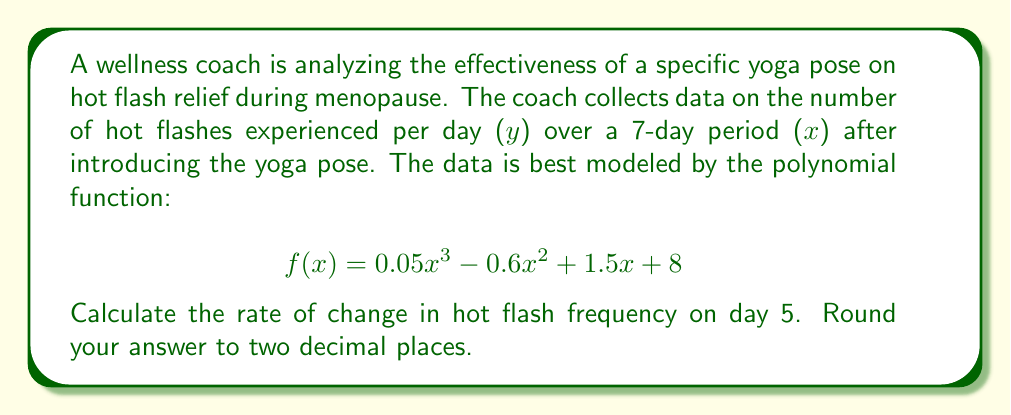What is the answer to this math problem? To find the rate of change in hot flash frequency on day 5, we need to calculate the derivative of the given polynomial function and evaluate it at x = 5.

Step 1: Find the derivative of f(x).
$$f(x) = 0.05x^3 - 0.6x^2 + 1.5x + 8$$
$$f'(x) = 0.15x^2 - 1.2x + 1.5$$

Step 2: Evaluate f'(x) at x = 5.
$$f'(5) = 0.15(5)^2 - 1.2(5) + 1.5$$
$$f'(5) = 0.15(25) - 6 + 1.5$$
$$f'(5) = 3.75 - 6 + 1.5$$
$$f'(5) = -0.75$$

Step 3: Round the result to two decimal places.
$$f'(5) \approx -0.75$$

The negative value indicates that the hot flash frequency is decreasing on day 5.
Answer: $-0.75$ hot flashes per day 